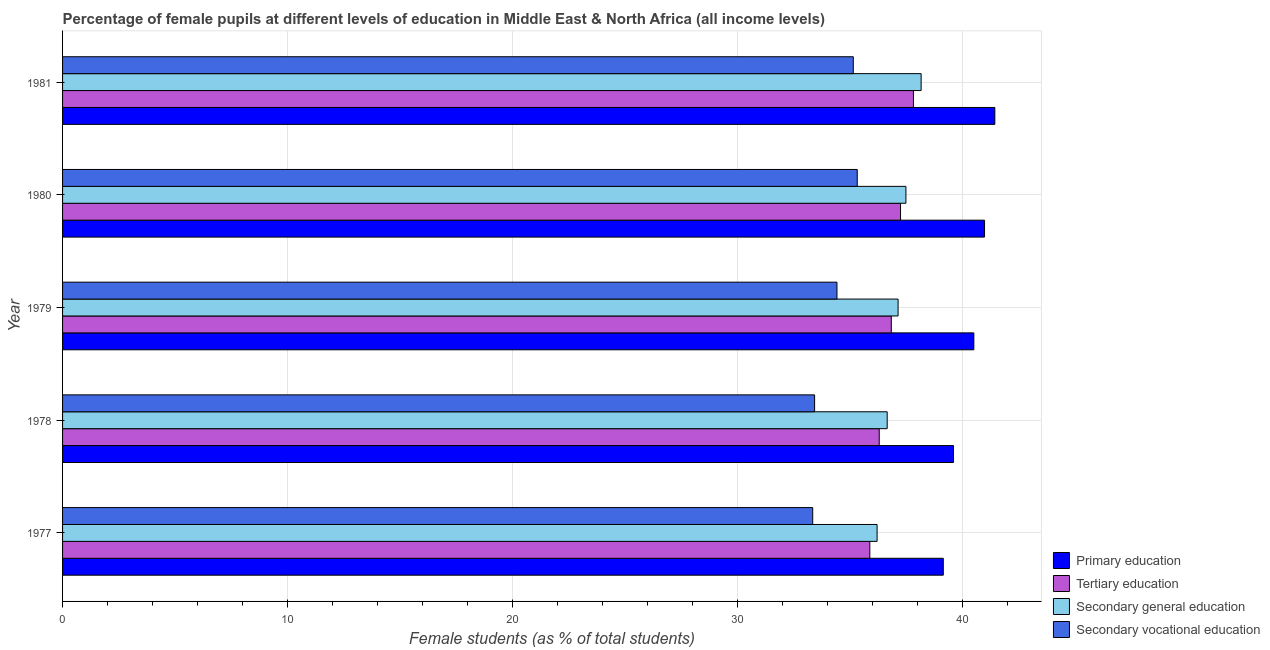How many groups of bars are there?
Offer a terse response. 5. Are the number of bars per tick equal to the number of legend labels?
Make the answer very short. Yes. How many bars are there on the 2nd tick from the bottom?
Offer a very short reply. 4. What is the label of the 4th group of bars from the top?
Provide a short and direct response. 1978. In how many cases, is the number of bars for a given year not equal to the number of legend labels?
Your answer should be compact. 0. What is the percentage of female students in secondary education in 1979?
Provide a short and direct response. 37.13. Across all years, what is the maximum percentage of female students in primary education?
Make the answer very short. 41.43. Across all years, what is the minimum percentage of female students in secondary education?
Keep it short and to the point. 36.2. In which year was the percentage of female students in primary education minimum?
Ensure brevity in your answer.  1977. What is the total percentage of female students in secondary vocational education in the graph?
Ensure brevity in your answer.  171.62. What is the difference between the percentage of female students in tertiary education in 1978 and that in 1979?
Your response must be concise. -0.54. What is the difference between the percentage of female students in secondary education in 1977 and the percentage of female students in primary education in 1978?
Your answer should be compact. -3.4. What is the average percentage of female students in secondary education per year?
Give a very brief answer. 37.12. In the year 1980, what is the difference between the percentage of female students in primary education and percentage of female students in tertiary education?
Ensure brevity in your answer.  3.73. Is the percentage of female students in secondary vocational education in 1979 less than that in 1980?
Make the answer very short. Yes. What is the difference between the highest and the second highest percentage of female students in primary education?
Ensure brevity in your answer.  0.46. What is the difference between the highest and the lowest percentage of female students in primary education?
Keep it short and to the point. 2.29. In how many years, is the percentage of female students in secondary education greater than the average percentage of female students in secondary education taken over all years?
Make the answer very short. 3. Is the sum of the percentage of female students in tertiary education in 1978 and 1981 greater than the maximum percentage of female students in primary education across all years?
Provide a short and direct response. Yes. Is it the case that in every year, the sum of the percentage of female students in secondary education and percentage of female students in primary education is greater than the sum of percentage of female students in secondary vocational education and percentage of female students in tertiary education?
Make the answer very short. Yes. What does the 3rd bar from the top in 1978 represents?
Provide a succinct answer. Tertiary education. What does the 2nd bar from the bottom in 1979 represents?
Provide a short and direct response. Tertiary education. How many bars are there?
Your answer should be compact. 20. How many years are there in the graph?
Offer a terse response. 5. Does the graph contain grids?
Provide a short and direct response. Yes. What is the title of the graph?
Make the answer very short. Percentage of female pupils at different levels of education in Middle East & North Africa (all income levels). Does "Tertiary schools" appear as one of the legend labels in the graph?
Give a very brief answer. No. What is the label or title of the X-axis?
Keep it short and to the point. Female students (as % of total students). What is the label or title of the Y-axis?
Ensure brevity in your answer.  Year. What is the Female students (as % of total students) of Primary education in 1977?
Your answer should be compact. 39.14. What is the Female students (as % of total students) in Tertiary education in 1977?
Provide a short and direct response. 35.87. What is the Female students (as % of total students) in Secondary general education in 1977?
Your answer should be very brief. 36.2. What is the Female students (as % of total students) in Secondary vocational education in 1977?
Your answer should be compact. 33.34. What is the Female students (as % of total students) in Primary education in 1978?
Your answer should be very brief. 39.59. What is the Female students (as % of total students) of Tertiary education in 1978?
Your response must be concise. 36.29. What is the Female students (as % of total students) of Secondary general education in 1978?
Keep it short and to the point. 36.65. What is the Female students (as % of total students) in Secondary vocational education in 1978?
Provide a short and direct response. 33.42. What is the Female students (as % of total students) in Primary education in 1979?
Your response must be concise. 40.5. What is the Female students (as % of total students) of Tertiary education in 1979?
Give a very brief answer. 36.83. What is the Female students (as % of total students) in Secondary general education in 1979?
Your answer should be compact. 37.13. What is the Female students (as % of total students) in Secondary vocational education in 1979?
Keep it short and to the point. 34.41. What is the Female students (as % of total students) of Primary education in 1980?
Your answer should be very brief. 40.97. What is the Female students (as % of total students) of Tertiary education in 1980?
Your response must be concise. 37.24. What is the Female students (as % of total students) of Secondary general education in 1980?
Provide a short and direct response. 37.48. What is the Female students (as % of total students) of Secondary vocational education in 1980?
Your answer should be very brief. 35.31. What is the Female students (as % of total students) of Primary education in 1981?
Make the answer very short. 41.43. What is the Female students (as % of total students) in Tertiary education in 1981?
Give a very brief answer. 37.81. What is the Female students (as % of total students) in Secondary general education in 1981?
Keep it short and to the point. 38.15. What is the Female students (as % of total students) of Secondary vocational education in 1981?
Your answer should be compact. 35.14. Across all years, what is the maximum Female students (as % of total students) in Primary education?
Provide a succinct answer. 41.43. Across all years, what is the maximum Female students (as % of total students) in Tertiary education?
Make the answer very short. 37.81. Across all years, what is the maximum Female students (as % of total students) of Secondary general education?
Your response must be concise. 38.15. Across all years, what is the maximum Female students (as % of total students) of Secondary vocational education?
Give a very brief answer. 35.31. Across all years, what is the minimum Female students (as % of total students) in Primary education?
Give a very brief answer. 39.14. Across all years, what is the minimum Female students (as % of total students) of Tertiary education?
Make the answer very short. 35.87. Across all years, what is the minimum Female students (as % of total students) of Secondary general education?
Offer a terse response. 36.2. Across all years, what is the minimum Female students (as % of total students) of Secondary vocational education?
Make the answer very short. 33.34. What is the total Female students (as % of total students) of Primary education in the graph?
Offer a terse response. 201.63. What is the total Female students (as % of total students) of Tertiary education in the graph?
Offer a terse response. 184.04. What is the total Female students (as % of total students) in Secondary general education in the graph?
Offer a terse response. 185.6. What is the total Female students (as % of total students) in Secondary vocational education in the graph?
Keep it short and to the point. 171.62. What is the difference between the Female students (as % of total students) in Primary education in 1977 and that in 1978?
Your response must be concise. -0.45. What is the difference between the Female students (as % of total students) in Tertiary education in 1977 and that in 1978?
Provide a succinct answer. -0.42. What is the difference between the Female students (as % of total students) in Secondary general education in 1977 and that in 1978?
Your response must be concise. -0.45. What is the difference between the Female students (as % of total students) of Secondary vocational education in 1977 and that in 1978?
Provide a succinct answer. -0.08. What is the difference between the Female students (as % of total students) in Primary education in 1977 and that in 1979?
Provide a succinct answer. -1.36. What is the difference between the Female students (as % of total students) in Tertiary education in 1977 and that in 1979?
Provide a succinct answer. -0.95. What is the difference between the Female students (as % of total students) in Secondary general education in 1977 and that in 1979?
Give a very brief answer. -0.93. What is the difference between the Female students (as % of total students) in Secondary vocational education in 1977 and that in 1979?
Provide a short and direct response. -1.08. What is the difference between the Female students (as % of total students) in Primary education in 1977 and that in 1980?
Ensure brevity in your answer.  -1.83. What is the difference between the Female students (as % of total students) of Tertiary education in 1977 and that in 1980?
Your answer should be compact. -1.36. What is the difference between the Female students (as % of total students) in Secondary general education in 1977 and that in 1980?
Provide a short and direct response. -1.28. What is the difference between the Female students (as % of total students) in Secondary vocational education in 1977 and that in 1980?
Your answer should be very brief. -1.98. What is the difference between the Female students (as % of total students) in Primary education in 1977 and that in 1981?
Your answer should be very brief. -2.29. What is the difference between the Female students (as % of total students) of Tertiary education in 1977 and that in 1981?
Provide a succinct answer. -1.94. What is the difference between the Female students (as % of total students) in Secondary general education in 1977 and that in 1981?
Ensure brevity in your answer.  -1.96. What is the difference between the Female students (as % of total students) of Secondary vocational education in 1977 and that in 1981?
Provide a succinct answer. -1.8. What is the difference between the Female students (as % of total students) of Primary education in 1978 and that in 1979?
Give a very brief answer. -0.9. What is the difference between the Female students (as % of total students) of Tertiary education in 1978 and that in 1979?
Your response must be concise. -0.54. What is the difference between the Female students (as % of total students) in Secondary general education in 1978 and that in 1979?
Keep it short and to the point. -0.48. What is the difference between the Female students (as % of total students) of Secondary vocational education in 1978 and that in 1979?
Your answer should be very brief. -0.99. What is the difference between the Female students (as % of total students) in Primary education in 1978 and that in 1980?
Provide a succinct answer. -1.38. What is the difference between the Female students (as % of total students) of Tertiary education in 1978 and that in 1980?
Provide a short and direct response. -0.95. What is the difference between the Female students (as % of total students) in Secondary general education in 1978 and that in 1980?
Ensure brevity in your answer.  -0.83. What is the difference between the Female students (as % of total students) in Secondary vocational education in 1978 and that in 1980?
Give a very brief answer. -1.89. What is the difference between the Female students (as % of total students) in Primary education in 1978 and that in 1981?
Make the answer very short. -1.84. What is the difference between the Female students (as % of total students) in Tertiary education in 1978 and that in 1981?
Make the answer very short. -1.52. What is the difference between the Female students (as % of total students) in Secondary general education in 1978 and that in 1981?
Provide a succinct answer. -1.51. What is the difference between the Female students (as % of total students) of Secondary vocational education in 1978 and that in 1981?
Give a very brief answer. -1.72. What is the difference between the Female students (as % of total students) of Primary education in 1979 and that in 1980?
Keep it short and to the point. -0.48. What is the difference between the Female students (as % of total students) in Tertiary education in 1979 and that in 1980?
Your answer should be very brief. -0.41. What is the difference between the Female students (as % of total students) in Secondary general education in 1979 and that in 1980?
Provide a short and direct response. -0.35. What is the difference between the Female students (as % of total students) in Secondary vocational education in 1979 and that in 1980?
Ensure brevity in your answer.  -0.9. What is the difference between the Female students (as % of total students) in Primary education in 1979 and that in 1981?
Make the answer very short. -0.93. What is the difference between the Female students (as % of total students) of Tertiary education in 1979 and that in 1981?
Your response must be concise. -0.98. What is the difference between the Female students (as % of total students) of Secondary general education in 1979 and that in 1981?
Offer a very short reply. -1.02. What is the difference between the Female students (as % of total students) in Secondary vocational education in 1979 and that in 1981?
Make the answer very short. -0.73. What is the difference between the Female students (as % of total students) in Primary education in 1980 and that in 1981?
Your answer should be compact. -0.46. What is the difference between the Female students (as % of total students) in Tertiary education in 1980 and that in 1981?
Provide a short and direct response. -0.57. What is the difference between the Female students (as % of total students) in Secondary general education in 1980 and that in 1981?
Give a very brief answer. -0.68. What is the difference between the Female students (as % of total students) of Secondary vocational education in 1980 and that in 1981?
Give a very brief answer. 0.18. What is the difference between the Female students (as % of total students) of Primary education in 1977 and the Female students (as % of total students) of Tertiary education in 1978?
Provide a succinct answer. 2.85. What is the difference between the Female students (as % of total students) of Primary education in 1977 and the Female students (as % of total students) of Secondary general education in 1978?
Your answer should be very brief. 2.49. What is the difference between the Female students (as % of total students) of Primary education in 1977 and the Female students (as % of total students) of Secondary vocational education in 1978?
Give a very brief answer. 5.72. What is the difference between the Female students (as % of total students) of Tertiary education in 1977 and the Female students (as % of total students) of Secondary general education in 1978?
Make the answer very short. -0.77. What is the difference between the Female students (as % of total students) of Tertiary education in 1977 and the Female students (as % of total students) of Secondary vocational education in 1978?
Your response must be concise. 2.45. What is the difference between the Female students (as % of total students) of Secondary general education in 1977 and the Female students (as % of total students) of Secondary vocational education in 1978?
Make the answer very short. 2.78. What is the difference between the Female students (as % of total students) of Primary education in 1977 and the Female students (as % of total students) of Tertiary education in 1979?
Offer a terse response. 2.31. What is the difference between the Female students (as % of total students) of Primary education in 1977 and the Female students (as % of total students) of Secondary general education in 1979?
Keep it short and to the point. 2.01. What is the difference between the Female students (as % of total students) in Primary education in 1977 and the Female students (as % of total students) in Secondary vocational education in 1979?
Keep it short and to the point. 4.73. What is the difference between the Female students (as % of total students) in Tertiary education in 1977 and the Female students (as % of total students) in Secondary general education in 1979?
Offer a very short reply. -1.26. What is the difference between the Female students (as % of total students) in Tertiary education in 1977 and the Female students (as % of total students) in Secondary vocational education in 1979?
Your response must be concise. 1.46. What is the difference between the Female students (as % of total students) in Secondary general education in 1977 and the Female students (as % of total students) in Secondary vocational education in 1979?
Your answer should be very brief. 1.78. What is the difference between the Female students (as % of total students) in Primary education in 1977 and the Female students (as % of total students) in Tertiary education in 1980?
Offer a very short reply. 1.9. What is the difference between the Female students (as % of total students) in Primary education in 1977 and the Female students (as % of total students) in Secondary general education in 1980?
Your answer should be compact. 1.66. What is the difference between the Female students (as % of total students) of Primary education in 1977 and the Female students (as % of total students) of Secondary vocational education in 1980?
Provide a succinct answer. 3.82. What is the difference between the Female students (as % of total students) of Tertiary education in 1977 and the Female students (as % of total students) of Secondary general education in 1980?
Keep it short and to the point. -1.6. What is the difference between the Female students (as % of total students) in Tertiary education in 1977 and the Female students (as % of total students) in Secondary vocational education in 1980?
Provide a succinct answer. 0.56. What is the difference between the Female students (as % of total students) of Secondary general education in 1977 and the Female students (as % of total students) of Secondary vocational education in 1980?
Offer a very short reply. 0.88. What is the difference between the Female students (as % of total students) in Primary education in 1977 and the Female students (as % of total students) in Tertiary education in 1981?
Give a very brief answer. 1.33. What is the difference between the Female students (as % of total students) in Primary education in 1977 and the Female students (as % of total students) in Secondary vocational education in 1981?
Your response must be concise. 4. What is the difference between the Female students (as % of total students) of Tertiary education in 1977 and the Female students (as % of total students) of Secondary general education in 1981?
Offer a terse response. -2.28. What is the difference between the Female students (as % of total students) of Tertiary education in 1977 and the Female students (as % of total students) of Secondary vocational education in 1981?
Make the answer very short. 0.74. What is the difference between the Female students (as % of total students) in Secondary general education in 1977 and the Female students (as % of total students) in Secondary vocational education in 1981?
Provide a succinct answer. 1.06. What is the difference between the Female students (as % of total students) in Primary education in 1978 and the Female students (as % of total students) in Tertiary education in 1979?
Provide a short and direct response. 2.76. What is the difference between the Female students (as % of total students) in Primary education in 1978 and the Female students (as % of total students) in Secondary general education in 1979?
Provide a short and direct response. 2.46. What is the difference between the Female students (as % of total students) in Primary education in 1978 and the Female students (as % of total students) in Secondary vocational education in 1979?
Your answer should be very brief. 5.18. What is the difference between the Female students (as % of total students) in Tertiary education in 1978 and the Female students (as % of total students) in Secondary general education in 1979?
Your answer should be very brief. -0.84. What is the difference between the Female students (as % of total students) in Tertiary education in 1978 and the Female students (as % of total students) in Secondary vocational education in 1979?
Your answer should be compact. 1.88. What is the difference between the Female students (as % of total students) of Secondary general education in 1978 and the Female students (as % of total students) of Secondary vocational education in 1979?
Keep it short and to the point. 2.23. What is the difference between the Female students (as % of total students) in Primary education in 1978 and the Female students (as % of total students) in Tertiary education in 1980?
Offer a terse response. 2.35. What is the difference between the Female students (as % of total students) in Primary education in 1978 and the Female students (as % of total students) in Secondary general education in 1980?
Make the answer very short. 2.11. What is the difference between the Female students (as % of total students) of Primary education in 1978 and the Female students (as % of total students) of Secondary vocational education in 1980?
Provide a short and direct response. 4.28. What is the difference between the Female students (as % of total students) in Tertiary education in 1978 and the Female students (as % of total students) in Secondary general education in 1980?
Make the answer very short. -1.19. What is the difference between the Female students (as % of total students) of Tertiary education in 1978 and the Female students (as % of total students) of Secondary vocational education in 1980?
Make the answer very short. 0.98. What is the difference between the Female students (as % of total students) of Secondary general education in 1978 and the Female students (as % of total students) of Secondary vocational education in 1980?
Keep it short and to the point. 1.33. What is the difference between the Female students (as % of total students) of Primary education in 1978 and the Female students (as % of total students) of Tertiary education in 1981?
Provide a short and direct response. 1.78. What is the difference between the Female students (as % of total students) of Primary education in 1978 and the Female students (as % of total students) of Secondary general education in 1981?
Ensure brevity in your answer.  1.44. What is the difference between the Female students (as % of total students) in Primary education in 1978 and the Female students (as % of total students) in Secondary vocational education in 1981?
Make the answer very short. 4.45. What is the difference between the Female students (as % of total students) of Tertiary education in 1978 and the Female students (as % of total students) of Secondary general education in 1981?
Keep it short and to the point. -1.86. What is the difference between the Female students (as % of total students) of Tertiary education in 1978 and the Female students (as % of total students) of Secondary vocational education in 1981?
Offer a terse response. 1.15. What is the difference between the Female students (as % of total students) in Secondary general education in 1978 and the Female students (as % of total students) in Secondary vocational education in 1981?
Your response must be concise. 1.51. What is the difference between the Female students (as % of total students) in Primary education in 1979 and the Female students (as % of total students) in Tertiary education in 1980?
Your answer should be compact. 3.26. What is the difference between the Female students (as % of total students) of Primary education in 1979 and the Female students (as % of total students) of Secondary general education in 1980?
Your response must be concise. 3.02. What is the difference between the Female students (as % of total students) in Primary education in 1979 and the Female students (as % of total students) in Secondary vocational education in 1980?
Make the answer very short. 5.18. What is the difference between the Female students (as % of total students) in Tertiary education in 1979 and the Female students (as % of total students) in Secondary general education in 1980?
Ensure brevity in your answer.  -0.65. What is the difference between the Female students (as % of total students) in Tertiary education in 1979 and the Female students (as % of total students) in Secondary vocational education in 1980?
Your answer should be compact. 1.51. What is the difference between the Female students (as % of total students) in Secondary general education in 1979 and the Female students (as % of total students) in Secondary vocational education in 1980?
Provide a short and direct response. 1.81. What is the difference between the Female students (as % of total students) of Primary education in 1979 and the Female students (as % of total students) of Tertiary education in 1981?
Offer a very short reply. 2.68. What is the difference between the Female students (as % of total students) of Primary education in 1979 and the Female students (as % of total students) of Secondary general education in 1981?
Offer a terse response. 2.34. What is the difference between the Female students (as % of total students) in Primary education in 1979 and the Female students (as % of total students) in Secondary vocational education in 1981?
Offer a terse response. 5.36. What is the difference between the Female students (as % of total students) of Tertiary education in 1979 and the Female students (as % of total students) of Secondary general education in 1981?
Make the answer very short. -1.33. What is the difference between the Female students (as % of total students) of Tertiary education in 1979 and the Female students (as % of total students) of Secondary vocational education in 1981?
Give a very brief answer. 1.69. What is the difference between the Female students (as % of total students) in Secondary general education in 1979 and the Female students (as % of total students) in Secondary vocational education in 1981?
Your answer should be compact. 1.99. What is the difference between the Female students (as % of total students) of Primary education in 1980 and the Female students (as % of total students) of Tertiary education in 1981?
Your answer should be compact. 3.16. What is the difference between the Female students (as % of total students) in Primary education in 1980 and the Female students (as % of total students) in Secondary general education in 1981?
Offer a terse response. 2.82. What is the difference between the Female students (as % of total students) of Primary education in 1980 and the Female students (as % of total students) of Secondary vocational education in 1981?
Make the answer very short. 5.83. What is the difference between the Female students (as % of total students) of Tertiary education in 1980 and the Female students (as % of total students) of Secondary general education in 1981?
Keep it short and to the point. -0.92. What is the difference between the Female students (as % of total students) in Tertiary education in 1980 and the Female students (as % of total students) in Secondary vocational education in 1981?
Provide a short and direct response. 2.1. What is the difference between the Female students (as % of total students) of Secondary general education in 1980 and the Female students (as % of total students) of Secondary vocational education in 1981?
Offer a very short reply. 2.34. What is the average Female students (as % of total students) in Primary education per year?
Offer a very short reply. 40.33. What is the average Female students (as % of total students) of Tertiary education per year?
Make the answer very short. 36.81. What is the average Female students (as % of total students) in Secondary general education per year?
Your response must be concise. 37.12. What is the average Female students (as % of total students) in Secondary vocational education per year?
Give a very brief answer. 34.32. In the year 1977, what is the difference between the Female students (as % of total students) in Primary education and Female students (as % of total students) in Tertiary education?
Offer a terse response. 3.27. In the year 1977, what is the difference between the Female students (as % of total students) of Primary education and Female students (as % of total students) of Secondary general education?
Your answer should be compact. 2.94. In the year 1977, what is the difference between the Female students (as % of total students) of Primary education and Female students (as % of total students) of Secondary vocational education?
Keep it short and to the point. 5.8. In the year 1977, what is the difference between the Female students (as % of total students) of Tertiary education and Female students (as % of total students) of Secondary general education?
Make the answer very short. -0.32. In the year 1977, what is the difference between the Female students (as % of total students) of Tertiary education and Female students (as % of total students) of Secondary vocational education?
Your answer should be compact. 2.54. In the year 1977, what is the difference between the Female students (as % of total students) of Secondary general education and Female students (as % of total students) of Secondary vocational education?
Provide a succinct answer. 2.86. In the year 1978, what is the difference between the Female students (as % of total students) in Primary education and Female students (as % of total students) in Tertiary education?
Your response must be concise. 3.3. In the year 1978, what is the difference between the Female students (as % of total students) in Primary education and Female students (as % of total students) in Secondary general education?
Offer a terse response. 2.95. In the year 1978, what is the difference between the Female students (as % of total students) of Primary education and Female students (as % of total students) of Secondary vocational education?
Make the answer very short. 6.17. In the year 1978, what is the difference between the Female students (as % of total students) of Tertiary education and Female students (as % of total students) of Secondary general education?
Offer a terse response. -0.35. In the year 1978, what is the difference between the Female students (as % of total students) in Tertiary education and Female students (as % of total students) in Secondary vocational education?
Your response must be concise. 2.87. In the year 1978, what is the difference between the Female students (as % of total students) of Secondary general education and Female students (as % of total students) of Secondary vocational education?
Make the answer very short. 3.23. In the year 1979, what is the difference between the Female students (as % of total students) in Primary education and Female students (as % of total students) in Tertiary education?
Provide a succinct answer. 3.67. In the year 1979, what is the difference between the Female students (as % of total students) of Primary education and Female students (as % of total students) of Secondary general education?
Your response must be concise. 3.37. In the year 1979, what is the difference between the Female students (as % of total students) in Primary education and Female students (as % of total students) in Secondary vocational education?
Give a very brief answer. 6.08. In the year 1979, what is the difference between the Female students (as % of total students) of Tertiary education and Female students (as % of total students) of Secondary general education?
Your answer should be compact. -0.3. In the year 1979, what is the difference between the Female students (as % of total students) in Tertiary education and Female students (as % of total students) in Secondary vocational education?
Provide a succinct answer. 2.41. In the year 1979, what is the difference between the Female students (as % of total students) of Secondary general education and Female students (as % of total students) of Secondary vocational education?
Ensure brevity in your answer.  2.72. In the year 1980, what is the difference between the Female students (as % of total students) of Primary education and Female students (as % of total students) of Tertiary education?
Your answer should be very brief. 3.73. In the year 1980, what is the difference between the Female students (as % of total students) of Primary education and Female students (as % of total students) of Secondary general education?
Provide a short and direct response. 3.49. In the year 1980, what is the difference between the Female students (as % of total students) of Primary education and Female students (as % of total students) of Secondary vocational education?
Your answer should be compact. 5.66. In the year 1980, what is the difference between the Female students (as % of total students) in Tertiary education and Female students (as % of total students) in Secondary general education?
Your answer should be compact. -0.24. In the year 1980, what is the difference between the Female students (as % of total students) in Tertiary education and Female students (as % of total students) in Secondary vocational education?
Offer a terse response. 1.92. In the year 1980, what is the difference between the Female students (as % of total students) of Secondary general education and Female students (as % of total students) of Secondary vocational education?
Ensure brevity in your answer.  2.16. In the year 1981, what is the difference between the Female students (as % of total students) in Primary education and Female students (as % of total students) in Tertiary education?
Ensure brevity in your answer.  3.62. In the year 1981, what is the difference between the Female students (as % of total students) of Primary education and Female students (as % of total students) of Secondary general education?
Your response must be concise. 3.28. In the year 1981, what is the difference between the Female students (as % of total students) of Primary education and Female students (as % of total students) of Secondary vocational education?
Your response must be concise. 6.29. In the year 1981, what is the difference between the Female students (as % of total students) in Tertiary education and Female students (as % of total students) in Secondary general education?
Provide a succinct answer. -0.34. In the year 1981, what is the difference between the Female students (as % of total students) of Tertiary education and Female students (as % of total students) of Secondary vocational education?
Give a very brief answer. 2.67. In the year 1981, what is the difference between the Female students (as % of total students) of Secondary general education and Female students (as % of total students) of Secondary vocational education?
Your answer should be very brief. 3.02. What is the ratio of the Female students (as % of total students) of Tertiary education in 1977 to that in 1978?
Offer a terse response. 0.99. What is the ratio of the Female students (as % of total students) of Primary education in 1977 to that in 1979?
Offer a very short reply. 0.97. What is the ratio of the Female students (as % of total students) in Tertiary education in 1977 to that in 1979?
Ensure brevity in your answer.  0.97. What is the ratio of the Female students (as % of total students) in Secondary general education in 1977 to that in 1979?
Ensure brevity in your answer.  0.97. What is the ratio of the Female students (as % of total students) in Secondary vocational education in 1977 to that in 1979?
Your answer should be compact. 0.97. What is the ratio of the Female students (as % of total students) of Primary education in 1977 to that in 1980?
Offer a terse response. 0.96. What is the ratio of the Female students (as % of total students) in Tertiary education in 1977 to that in 1980?
Ensure brevity in your answer.  0.96. What is the ratio of the Female students (as % of total students) in Secondary general education in 1977 to that in 1980?
Offer a terse response. 0.97. What is the ratio of the Female students (as % of total students) of Secondary vocational education in 1977 to that in 1980?
Offer a terse response. 0.94. What is the ratio of the Female students (as % of total students) of Primary education in 1977 to that in 1981?
Keep it short and to the point. 0.94. What is the ratio of the Female students (as % of total students) of Tertiary education in 1977 to that in 1981?
Provide a succinct answer. 0.95. What is the ratio of the Female students (as % of total students) in Secondary general education in 1977 to that in 1981?
Your answer should be very brief. 0.95. What is the ratio of the Female students (as % of total students) in Secondary vocational education in 1977 to that in 1981?
Provide a short and direct response. 0.95. What is the ratio of the Female students (as % of total students) of Primary education in 1978 to that in 1979?
Provide a succinct answer. 0.98. What is the ratio of the Female students (as % of total students) in Tertiary education in 1978 to that in 1979?
Your response must be concise. 0.99. What is the ratio of the Female students (as % of total students) in Secondary general education in 1978 to that in 1979?
Ensure brevity in your answer.  0.99. What is the ratio of the Female students (as % of total students) of Secondary vocational education in 1978 to that in 1979?
Offer a terse response. 0.97. What is the ratio of the Female students (as % of total students) in Primary education in 1978 to that in 1980?
Offer a very short reply. 0.97. What is the ratio of the Female students (as % of total students) in Tertiary education in 1978 to that in 1980?
Offer a terse response. 0.97. What is the ratio of the Female students (as % of total students) in Secondary general education in 1978 to that in 1980?
Your answer should be very brief. 0.98. What is the ratio of the Female students (as % of total students) in Secondary vocational education in 1978 to that in 1980?
Offer a very short reply. 0.95. What is the ratio of the Female students (as % of total students) of Primary education in 1978 to that in 1981?
Provide a short and direct response. 0.96. What is the ratio of the Female students (as % of total students) of Tertiary education in 1978 to that in 1981?
Keep it short and to the point. 0.96. What is the ratio of the Female students (as % of total students) of Secondary general education in 1978 to that in 1981?
Keep it short and to the point. 0.96. What is the ratio of the Female students (as % of total students) in Secondary vocational education in 1978 to that in 1981?
Provide a short and direct response. 0.95. What is the ratio of the Female students (as % of total students) of Primary education in 1979 to that in 1980?
Ensure brevity in your answer.  0.99. What is the ratio of the Female students (as % of total students) in Secondary general education in 1979 to that in 1980?
Your response must be concise. 0.99. What is the ratio of the Female students (as % of total students) in Secondary vocational education in 1979 to that in 1980?
Provide a succinct answer. 0.97. What is the ratio of the Female students (as % of total students) in Primary education in 1979 to that in 1981?
Your answer should be compact. 0.98. What is the ratio of the Female students (as % of total students) of Tertiary education in 1979 to that in 1981?
Your answer should be compact. 0.97. What is the ratio of the Female students (as % of total students) of Secondary general education in 1979 to that in 1981?
Offer a terse response. 0.97. What is the ratio of the Female students (as % of total students) in Secondary vocational education in 1979 to that in 1981?
Ensure brevity in your answer.  0.98. What is the ratio of the Female students (as % of total students) in Primary education in 1980 to that in 1981?
Offer a very short reply. 0.99. What is the ratio of the Female students (as % of total students) in Secondary general education in 1980 to that in 1981?
Offer a terse response. 0.98. What is the ratio of the Female students (as % of total students) in Secondary vocational education in 1980 to that in 1981?
Make the answer very short. 1. What is the difference between the highest and the second highest Female students (as % of total students) in Primary education?
Your answer should be very brief. 0.46. What is the difference between the highest and the second highest Female students (as % of total students) of Tertiary education?
Make the answer very short. 0.57. What is the difference between the highest and the second highest Female students (as % of total students) in Secondary general education?
Ensure brevity in your answer.  0.68. What is the difference between the highest and the second highest Female students (as % of total students) of Secondary vocational education?
Your answer should be very brief. 0.18. What is the difference between the highest and the lowest Female students (as % of total students) in Primary education?
Your answer should be compact. 2.29. What is the difference between the highest and the lowest Female students (as % of total students) of Tertiary education?
Offer a terse response. 1.94. What is the difference between the highest and the lowest Female students (as % of total students) of Secondary general education?
Offer a terse response. 1.96. What is the difference between the highest and the lowest Female students (as % of total students) of Secondary vocational education?
Make the answer very short. 1.98. 